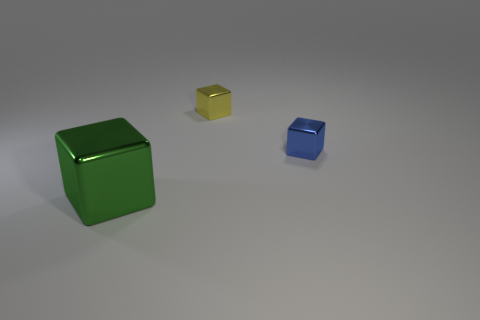Subtract all tiny blue metal cubes. How many cubes are left? 2 Add 1 yellow balls. How many objects exist? 4 Subtract all blue cubes. How many cubes are left? 2 Subtract 1 blocks. How many blocks are left? 2 Subtract all green blocks. Subtract all red cylinders. How many blocks are left? 2 Subtract all cyan cylinders. How many yellow cubes are left? 1 Subtract all small blue cubes. Subtract all big green matte things. How many objects are left? 2 Add 3 green blocks. How many green blocks are left? 4 Add 2 brown rubber spheres. How many brown rubber spheres exist? 2 Subtract 0 blue balls. How many objects are left? 3 